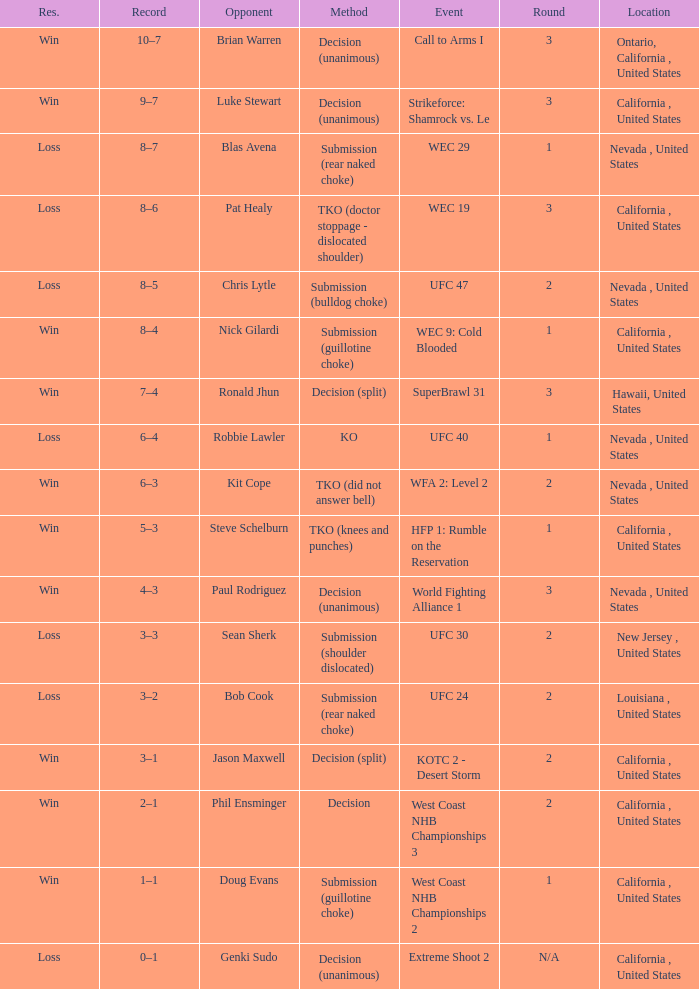What is the result for the Call to Arms I event? Win. 